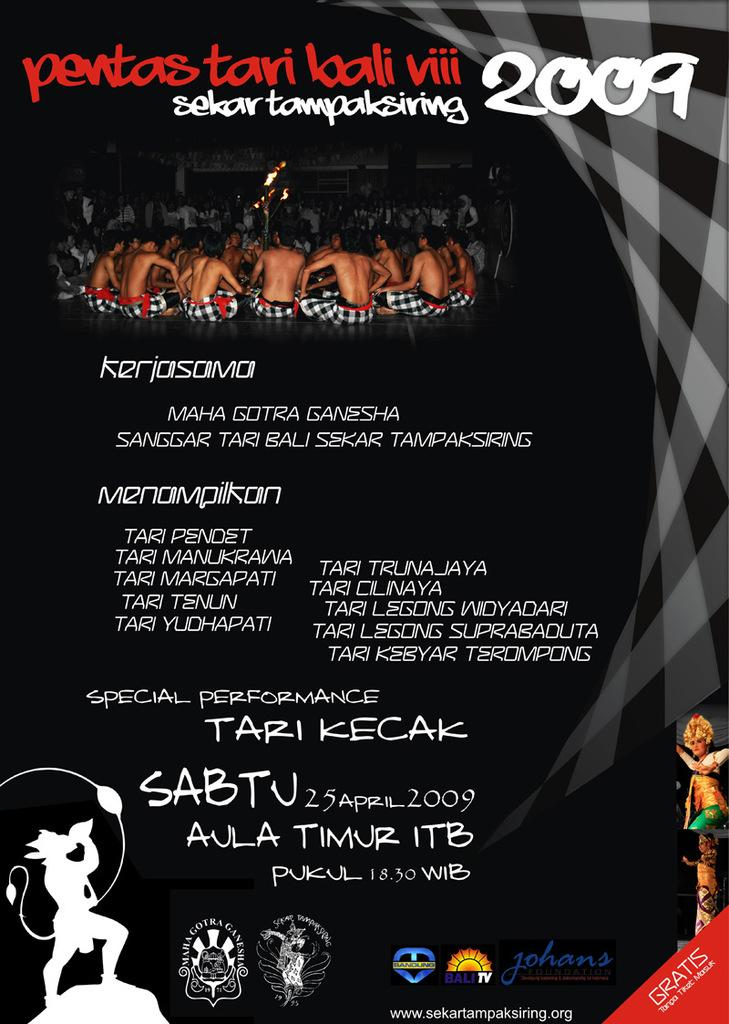<image>
Offer a succinct explanation of the picture presented. An entertainment poster advertises an event from 2009. 